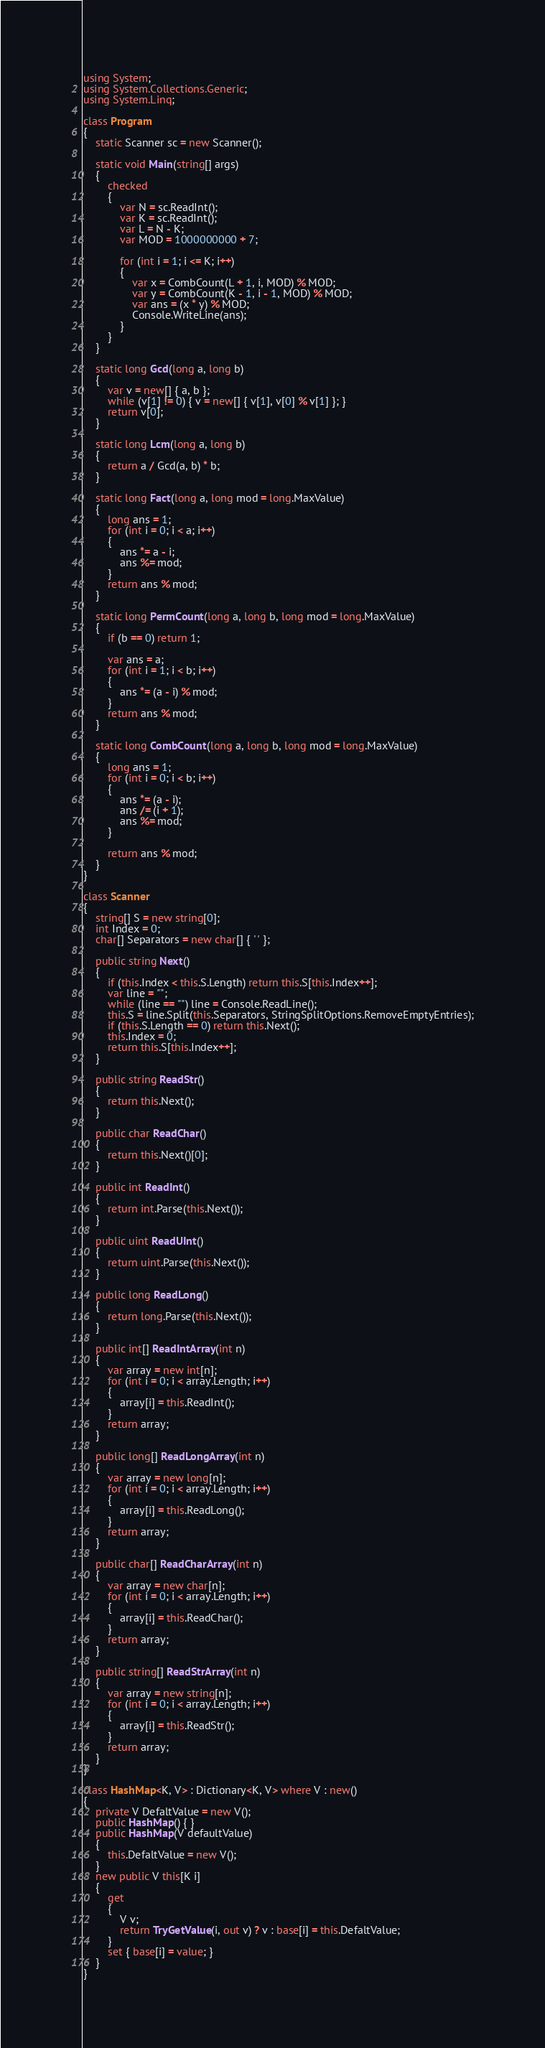<code> <loc_0><loc_0><loc_500><loc_500><_C#_>using System;
using System.Collections.Generic;
using System.Linq;

class Program
{
    static Scanner sc = new Scanner();

    static void Main(string[] args)
    {
        checked
        {
            var N = sc.ReadInt();
            var K = sc.ReadInt();
            var L = N - K;
            var MOD = 1000000000 + 7;

            for (int i = 1; i <= K; i++)
            {
                var x = CombCount(L + 1, i, MOD) % MOD;
                var y = CombCount(K - 1, i - 1, MOD) % MOD;
                var ans = (x * y) % MOD;
                Console.WriteLine(ans);
            }
        }
    }

    static long Gcd(long a, long b)
    {
        var v = new[] { a, b };
        while (v[1] != 0) { v = new[] { v[1], v[0] % v[1] }; }
        return v[0];
    }

    static long Lcm(long a, long b)
    {
        return a / Gcd(a, b) * b;
    }

    static long Fact(long a, long mod = long.MaxValue)
    {
        long ans = 1;
        for (int i = 0; i < a; i++)
        {
            ans *= a - i;
            ans %= mod;
        }
        return ans % mod;
    }

    static long PermCount(long a, long b, long mod = long.MaxValue)
    {
        if (b == 0) return 1;

        var ans = a;
        for (int i = 1; i < b; i++)
        {
            ans *= (a - i) % mod;
        }
        return ans % mod;
    }

    static long CombCount(long a, long b, long mod = long.MaxValue)
    {
        long ans = 1;
        for (int i = 0; i < b; i++)
        {
            ans *= (a - i);
            ans /= (i + 1);
            ans %= mod;
        }

        return ans % mod;
    }
}

class Scanner
{
    string[] S = new string[0];
    int Index = 0;
    char[] Separators = new char[] { ' ' };

    public string Next()
    {
        if (this.Index < this.S.Length) return this.S[this.Index++];
        var line = "";
        while (line == "") line = Console.ReadLine();
        this.S = line.Split(this.Separators, StringSplitOptions.RemoveEmptyEntries);
        if (this.S.Length == 0) return this.Next();
        this.Index = 0;
        return this.S[this.Index++];
    }

    public string ReadStr()
    {
        return this.Next();
    }

    public char ReadChar()
    {
        return this.Next()[0];
    }

    public int ReadInt()
    {
        return int.Parse(this.Next());
    }

    public uint ReadUInt()
    {
        return uint.Parse(this.Next());
    }

    public long ReadLong()
    {
        return long.Parse(this.Next());
    }

    public int[] ReadIntArray(int n)
    {
        var array = new int[n];
        for (int i = 0; i < array.Length; i++)
        {
            array[i] = this.ReadInt();
        }
        return array;
    }

    public long[] ReadLongArray(int n)
    {
        var array = new long[n];
        for (int i = 0; i < array.Length; i++)
        {
            array[i] = this.ReadLong();
        }
        return array;
    }

    public char[] ReadCharArray(int n)
    {
        var array = new char[n];
        for (int i = 0; i < array.Length; i++)
        {
            array[i] = this.ReadChar();
        }
        return array;
    }

    public string[] ReadStrArray(int n)
    {
        var array = new string[n];
        for (int i = 0; i < array.Length; i++)
        {
            array[i] = this.ReadStr();
        }
        return array;
    }
}

class HashMap<K, V> : Dictionary<K, V> where V : new()
{
    private V DefaltValue = new V();
    public HashMap() { }
    public HashMap(V defaultValue)
    {
        this.DefaltValue = new V();
    }
    new public V this[K i]
    {
        get
        {
            V v;
            return TryGetValue(i, out v) ? v : base[i] = this.DefaltValue;
        }
        set { base[i] = value; }
    }
}</code> 